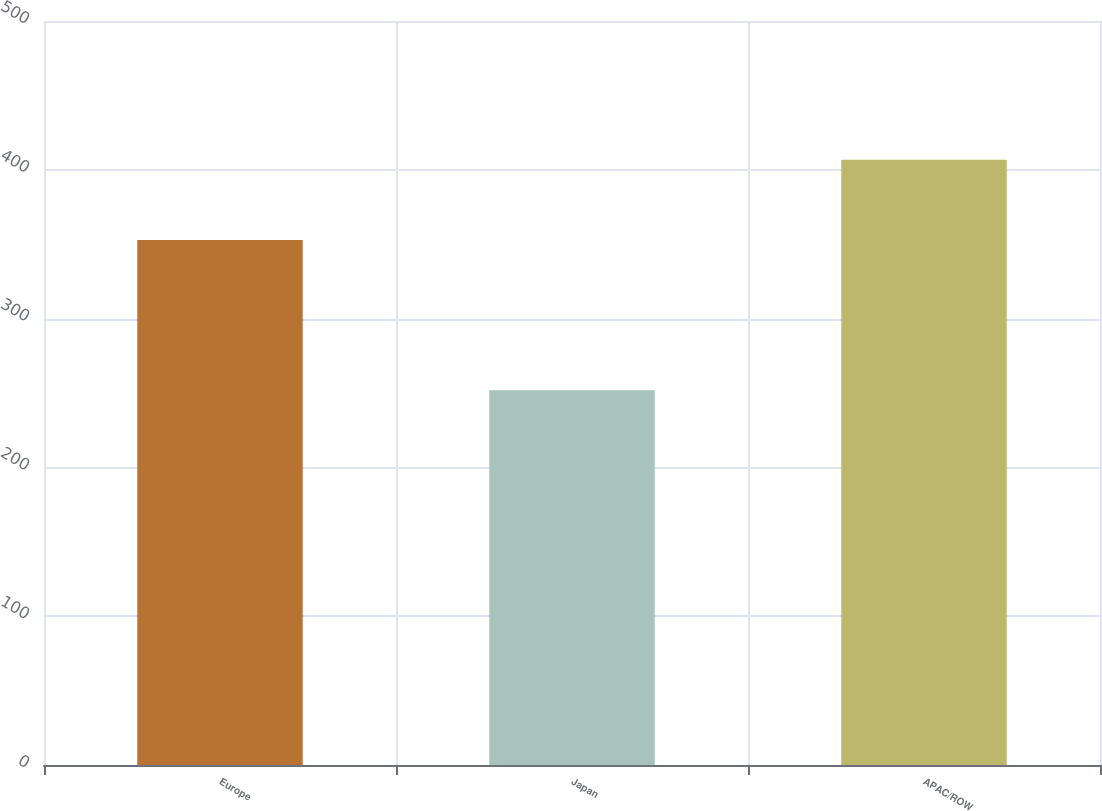Convert chart to OTSL. <chart><loc_0><loc_0><loc_500><loc_500><bar_chart><fcel>Europe<fcel>Japan<fcel>APAC/ROW<nl><fcel>352.8<fcel>251.8<fcel>406.7<nl></chart> 